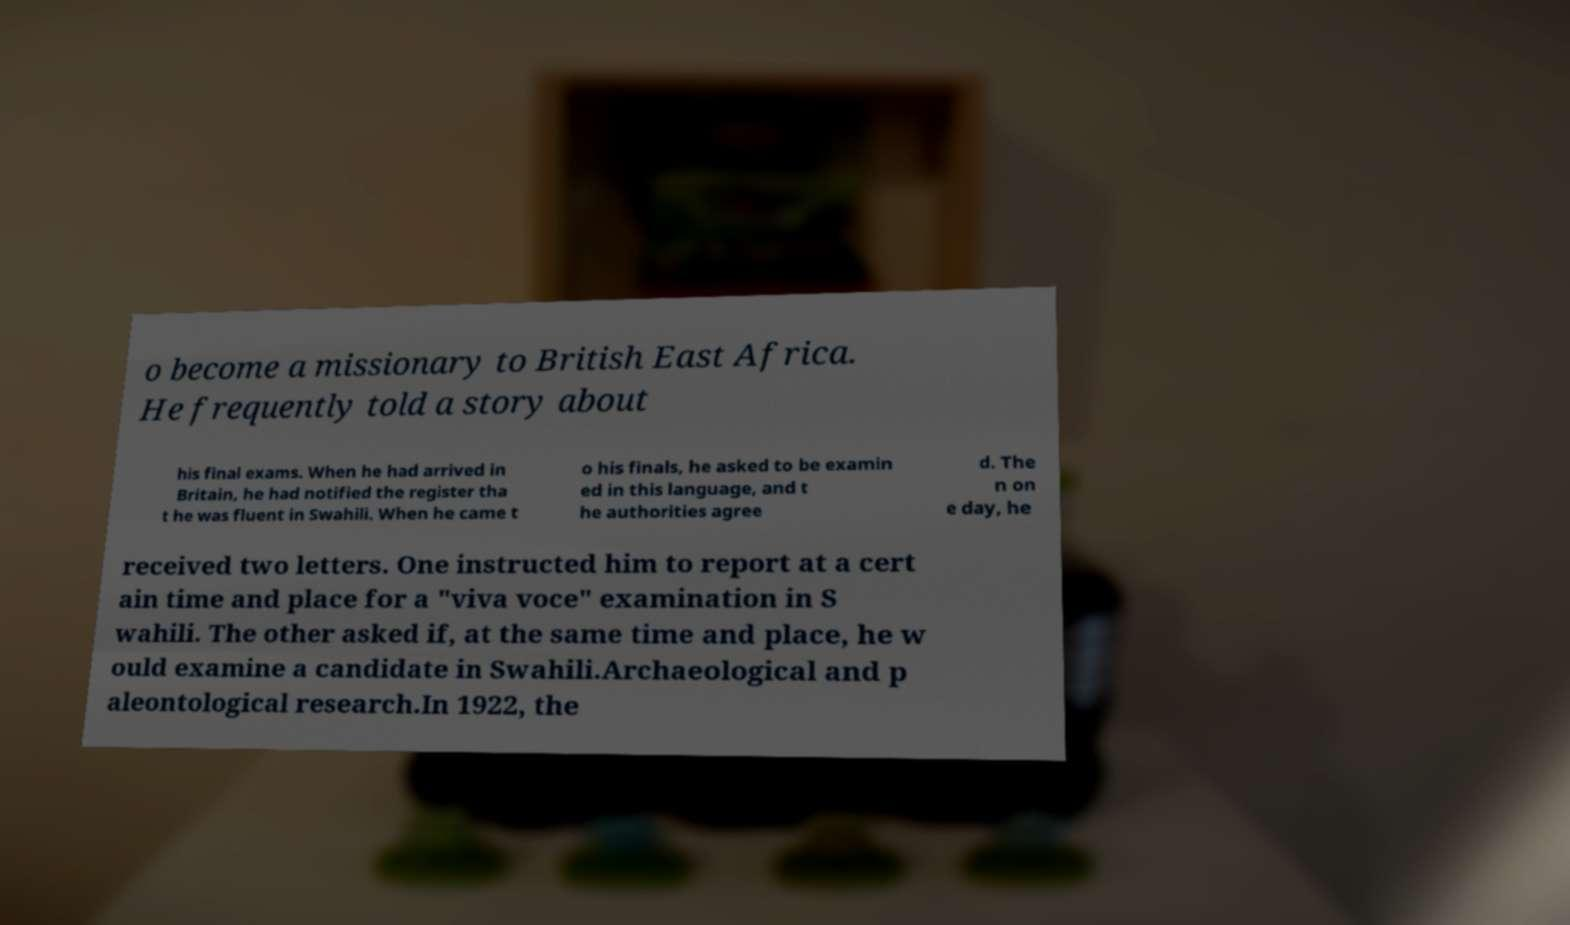For documentation purposes, I need the text within this image transcribed. Could you provide that? o become a missionary to British East Africa. He frequently told a story about his final exams. When he had arrived in Britain, he had notified the register tha t he was fluent in Swahili. When he came t o his finals, he asked to be examin ed in this language, and t he authorities agree d. The n on e day, he received two letters. One instructed him to report at a cert ain time and place for a "viva voce" examination in S wahili. The other asked if, at the same time and place, he w ould examine a candidate in Swahili.Archaeological and p aleontological research.In 1922, the 